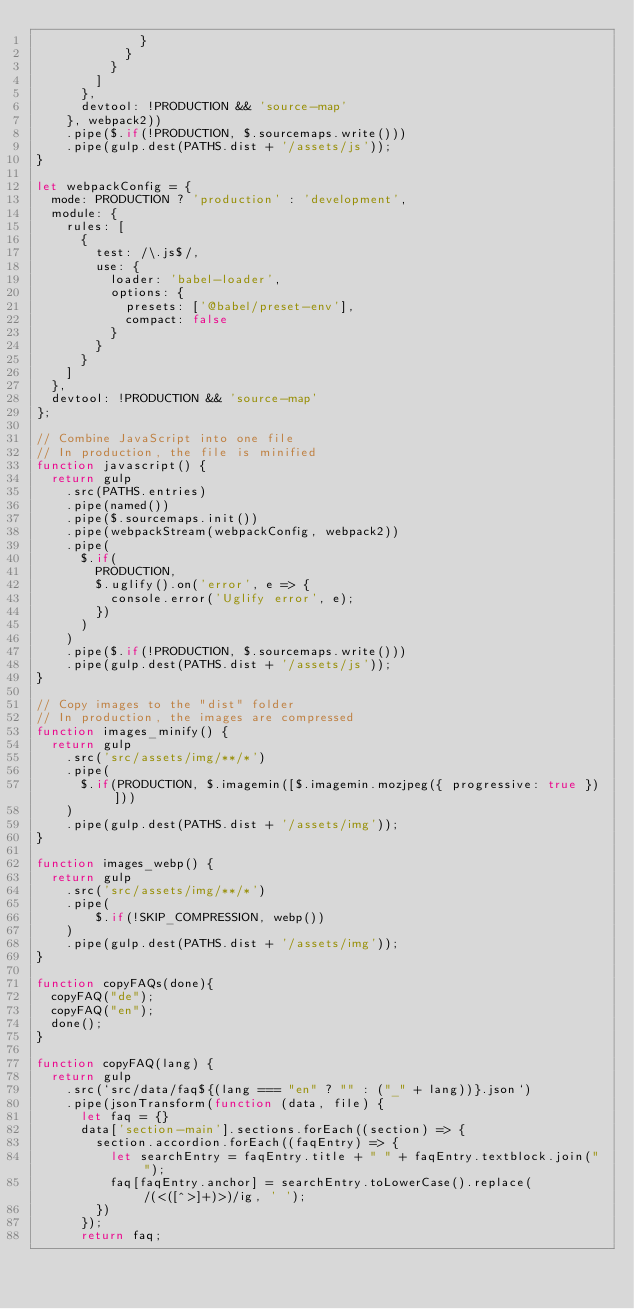Convert code to text. <code><loc_0><loc_0><loc_500><loc_500><_JavaScript_>              }
            }
          }
        ]
      },
      devtool: !PRODUCTION && 'source-map'
    }, webpack2))
    .pipe($.if(!PRODUCTION, $.sourcemaps.write()))
    .pipe(gulp.dest(PATHS.dist + '/assets/js'));
}

let webpackConfig = {
  mode: PRODUCTION ? 'production' : 'development',
  module: {
    rules: [
      {
        test: /\.js$/,
        use: {
          loader: 'babel-loader',
          options: {
            presets: ['@babel/preset-env'],
            compact: false
          }
        }
      }
    ]
  },
  devtool: !PRODUCTION && 'source-map'
};

// Combine JavaScript into one file
// In production, the file is minified
function javascript() {
  return gulp
    .src(PATHS.entries)
    .pipe(named())
    .pipe($.sourcemaps.init())
    .pipe(webpackStream(webpackConfig, webpack2))
    .pipe(
      $.if(
        PRODUCTION,
        $.uglify().on('error', e => {
          console.error('Uglify error', e);
        })
      )
    )
    .pipe($.if(!PRODUCTION, $.sourcemaps.write()))
    .pipe(gulp.dest(PATHS.dist + '/assets/js'));
}

// Copy images to the "dist" folder
// In production, the images are compressed
function images_minify() {
  return gulp
    .src('src/assets/img/**/*')
    .pipe(
      $.if(PRODUCTION, $.imagemin([$.imagemin.mozjpeg({ progressive: true })]))
    )
    .pipe(gulp.dest(PATHS.dist + '/assets/img'));
}

function images_webp() {
  return gulp
    .src('src/assets/img/**/*')
    .pipe(
        $.if(!SKIP_COMPRESSION, webp())
    )
    .pipe(gulp.dest(PATHS.dist + '/assets/img'));
}

function copyFAQs(done){
  copyFAQ("de");
  copyFAQ("en");
  done();
}

function copyFAQ(lang) {
  return gulp
    .src(`src/data/faq${(lang === "en" ? "" : ("_" + lang))}.json`)
    .pipe(jsonTransform(function (data, file) {
      let faq = {}
      data['section-main'].sections.forEach((section) => {
        section.accordion.forEach((faqEntry) => {
          let searchEntry = faqEntry.title + " " + faqEntry.textblock.join(" ");
          faq[faqEntry.anchor] = searchEntry.toLowerCase().replace( /(<([^>]+)>)/ig, ' ');
        })
      });
      return faq;</code> 